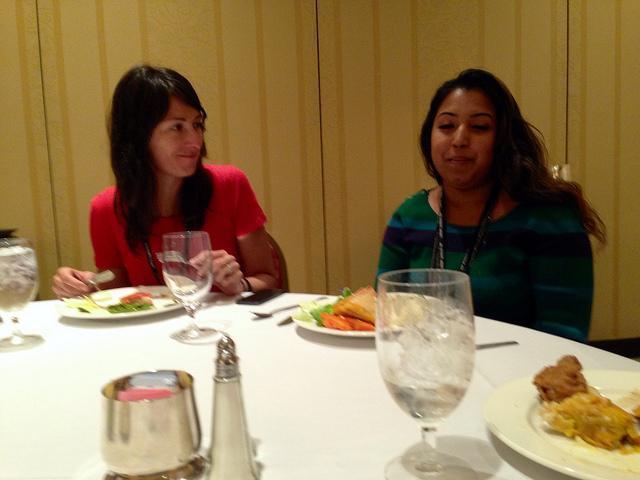What part of the meal is being eaten?
Make your selection from the four choices given to correctly answer the question.
Options: Soup, entree, salad, dessert. Entree. 